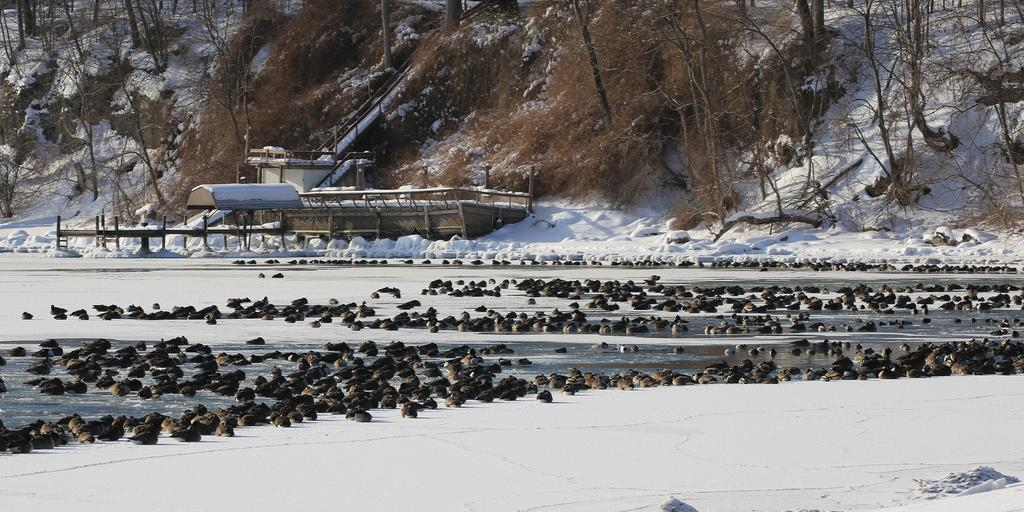What type of animals can be seen in the water in the image? There are aquatic animals in the water in the center of the image. What is the condition of the ground in the front of the image? There is snow in the front of the image. What can be seen in the background of the image? There are trees and a wooden shelter in the background of the image. What detail does the writer add to the image to make it more interesting? There is no writer present in the image, and therefore no additional details can be added. 